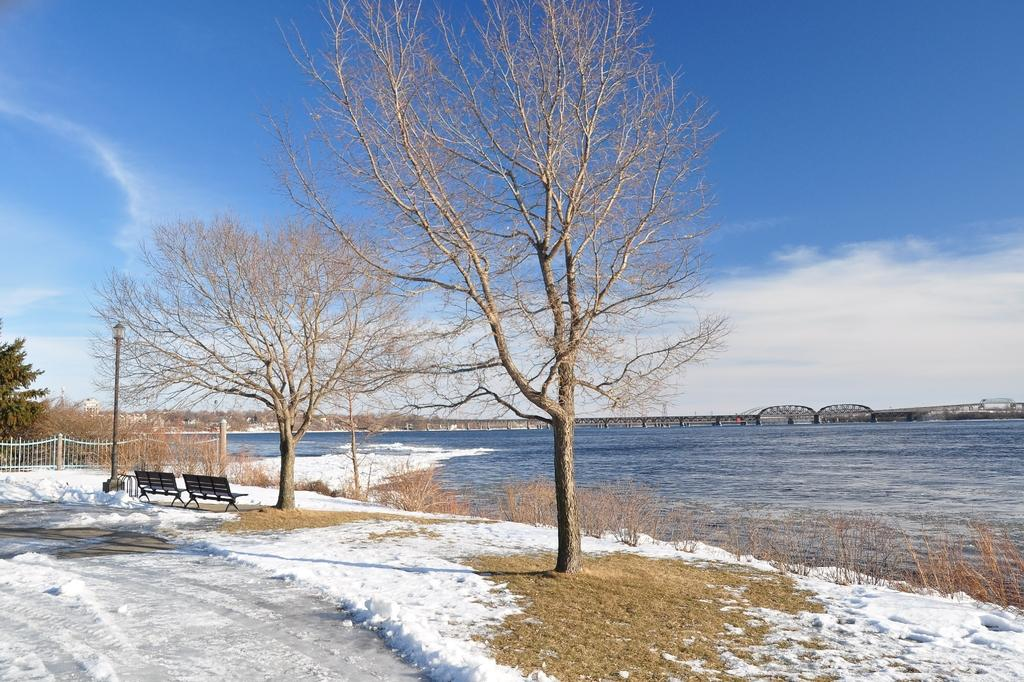What type of vegetation can be seen in the image? There are trees and grass in the image. What type of seating is available in the image? There are benches in the image. What type of lighting is present in the image? There is a street lamp in the image. What type of barrier is present in the image? There is a fence in the image. What part of the natural environment is visible in the image? The sky is visible in the image. What type of structure can be seen in the background of the image? There is a bridge in the background of the image. What type of body of water is visible in the background of the image? There is water in the background of the image. Can you tell me how many yaks are grazing on the grass in the image? There are no yaks present in the image; it features trees, grass, benches, a street lamp, a fence, the sky, a bridge, and water in the background. What type of loss is being experienced by the person in the image? There is no person present in the image, and therefore no loss can be observed. 